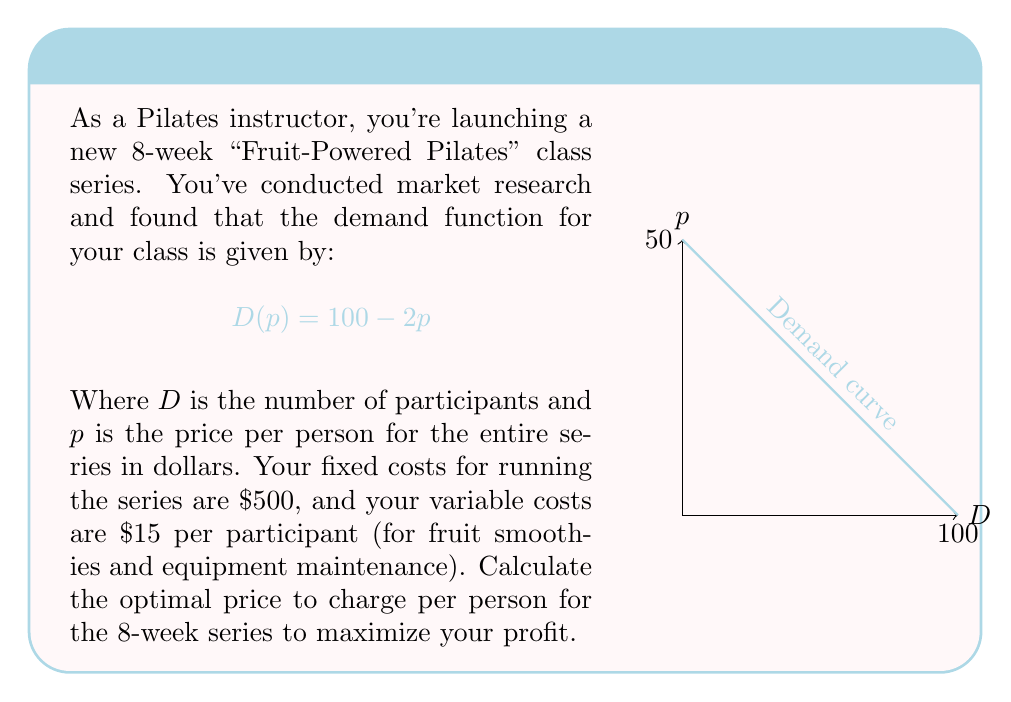Can you answer this question? Let's approach this step-by-step:

1) First, we need to set up our profit function. Profit is revenue minus costs.

2) Revenue is price times quantity: $R = pD(p) = p(100-2p) = 100p - 2p^2$

3) Total cost is fixed cost plus variable cost times quantity:
   $C = 500 + 15D(p) = 500 + 15(100-2p) = 2000 - 30p$

4) Therefore, our profit function is:
   $$\pi(p) = R - C = (100p - 2p^2) - (2000 - 30p) = -2p^2 + 130p - 2000$$

5) To find the maximum profit, we differentiate $\pi(p)$ with respect to $p$ and set it to zero:
   $$\frac{d\pi}{dp} = -4p + 130 = 0$$

6) Solving this equation:
   $$-4p + 130 = 0$$
   $$-4p = -130$$
   $$p = 32.5$$

7) To confirm this is a maximum, we can check the second derivative:
   $$\frac{d^2\pi}{dp^2} = -4$$
   Since this is negative, we confirm that $p = 32.5$ gives a maximum.

8) Therefore, the optimal price is $32.50 per person for the 8-week series.
Answer: $32.50 